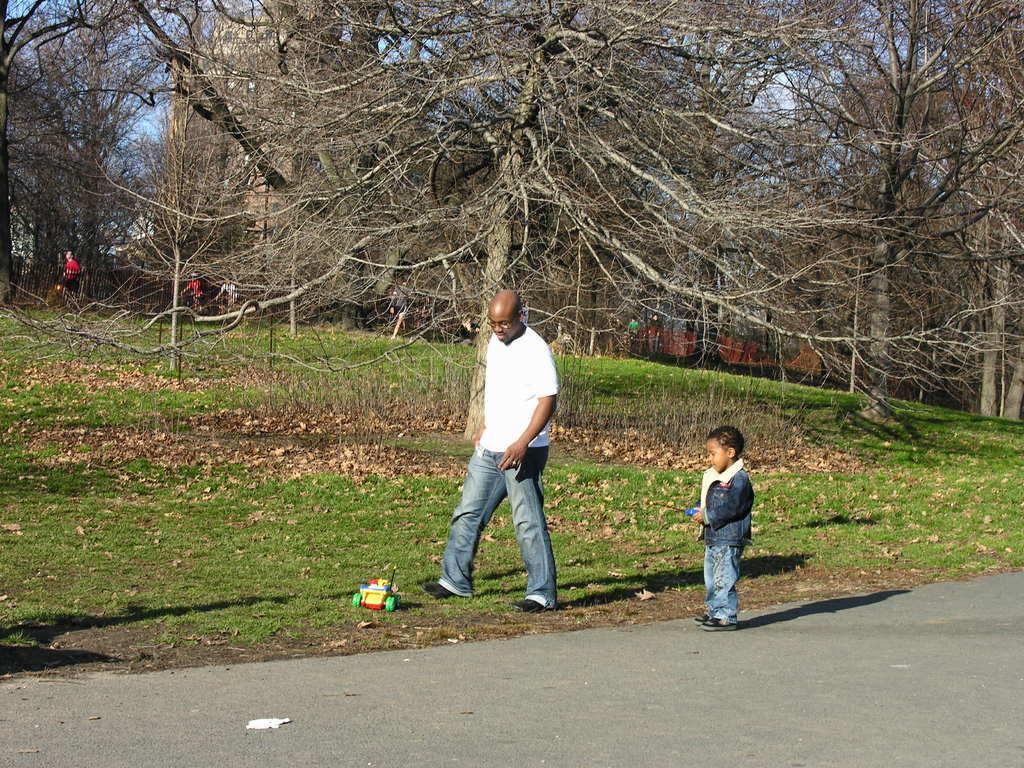Could you give a brief overview of what you see in this image? In this picture I can see a man and a boy is standing on the ground. I can also see toy, grass trees, road and sky in the background. 